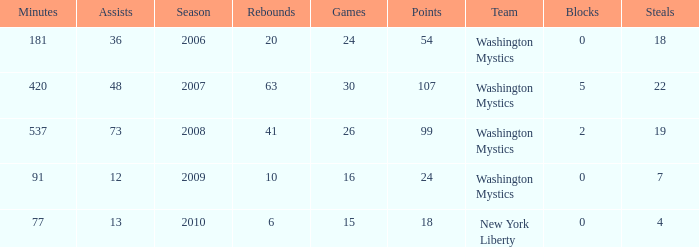What is the earliest year that Assists were less than 13 and minutes were under 91? None. 